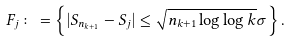<formula> <loc_0><loc_0><loc_500><loc_500>F _ { j } \colon = \left \{ | S _ { n _ { k + 1 } } - S _ { j } | \leq \sqrt { n _ { k + 1 } \log \log k } \sigma \right \} .</formula> 